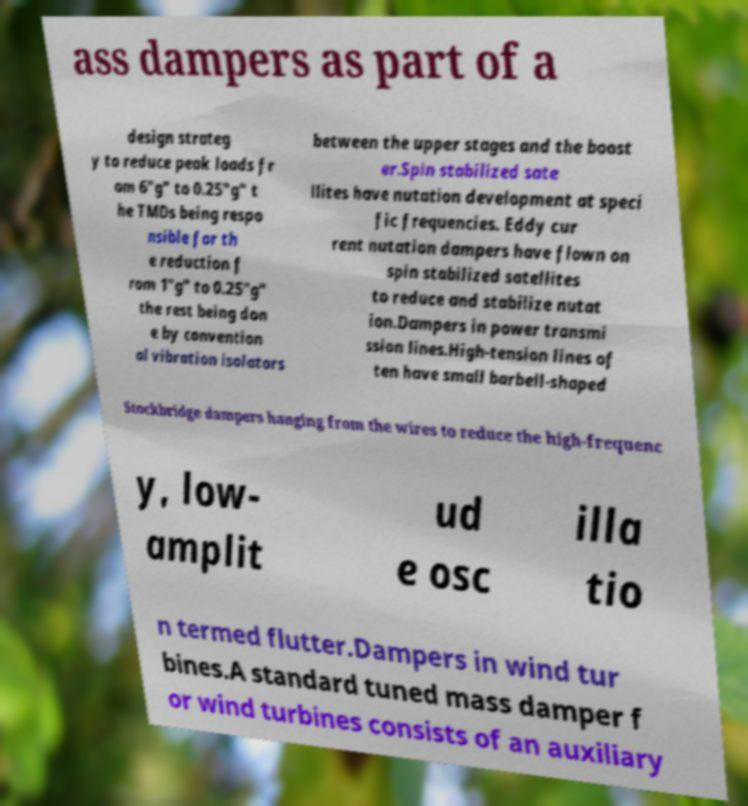Can you read and provide the text displayed in the image?This photo seems to have some interesting text. Can you extract and type it out for me? ass dampers as part of a design strateg y to reduce peak loads fr om 6"g" to 0.25"g" t he TMDs being respo nsible for th e reduction f rom 1"g" to 0.25"g" the rest being don e by convention al vibration isolators between the upper stages and the boost er.Spin stabilized sate llites have nutation development at speci fic frequencies. Eddy cur rent nutation dampers have flown on spin stabilized satellites to reduce and stabilize nutat ion.Dampers in power transmi ssion lines.High-tension lines of ten have small barbell-shaped Stockbridge dampers hanging from the wires to reduce the high-frequenc y, low- amplit ud e osc illa tio n termed flutter.Dampers in wind tur bines.A standard tuned mass damper f or wind turbines consists of an auxiliary 